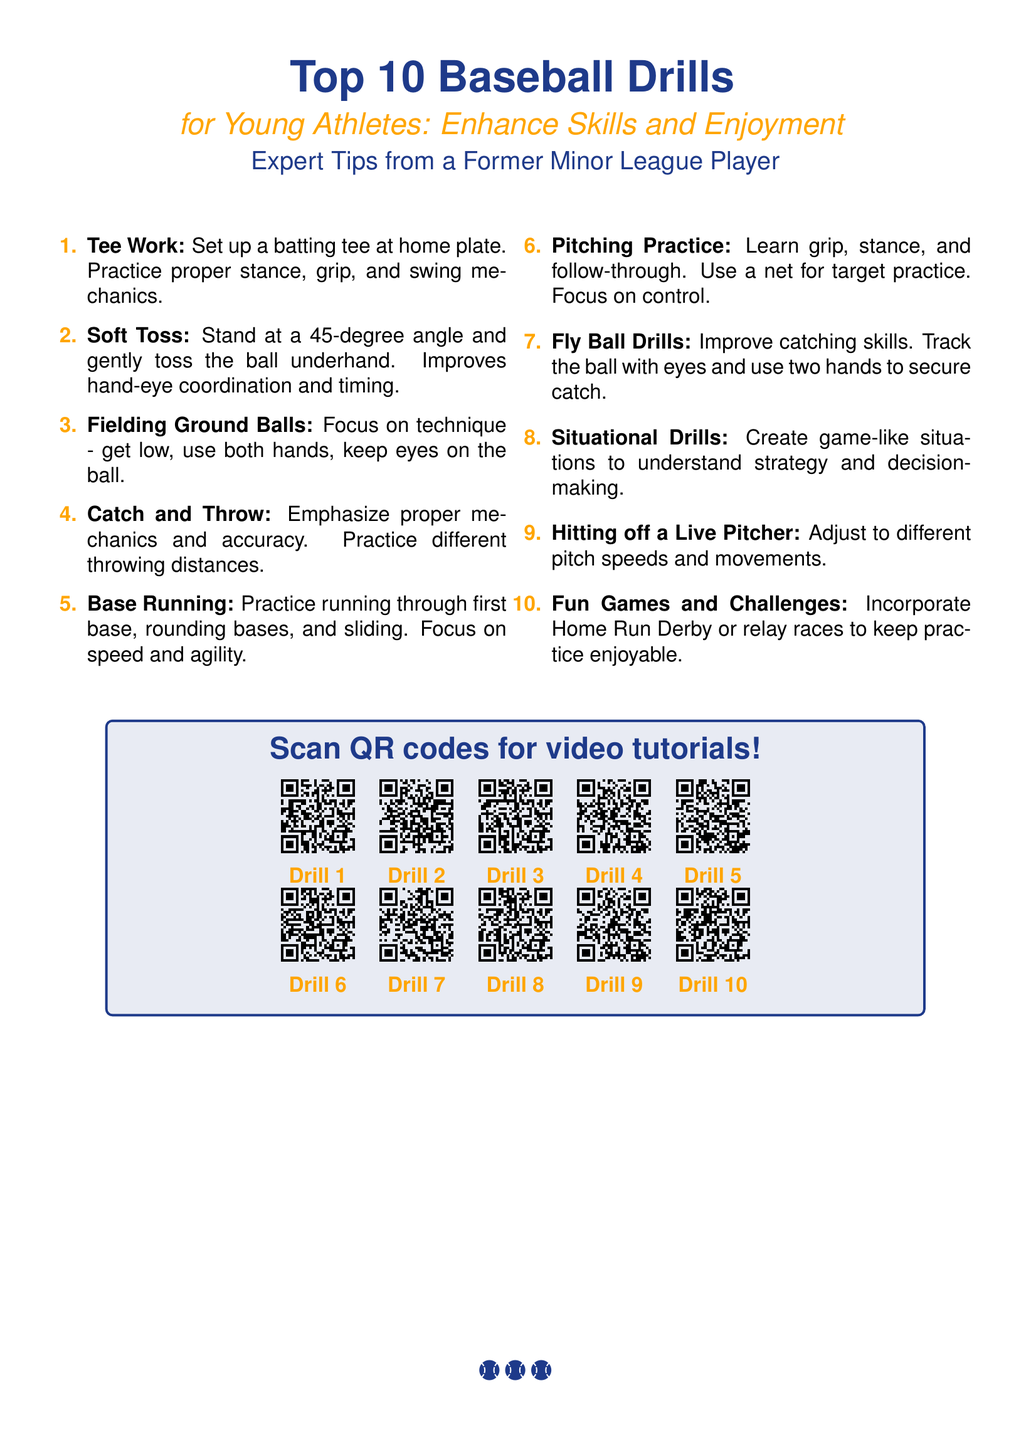What is the title of the flyer? The title of the flyer is prominently displayed at the top and reads "Top 10 Baseball Drills."
Answer: Top 10 Baseball Drills How many drills are listed in the document? The document enumerates each drill, making it clear that there are ten drills in total.
Answer: 10 What is the color used for the accent in the flyer? The accent color is mentioned in the document and is identified by its HTML code.
Answer: #FFA500 Which drill focuses on improving hand-eye coordination and timing? The document describes the purpose of the drills, indicating that Soft Toss is aimed at improving hand-eye coordination and timing.
Answer: Soft Toss What is emphasized during the Pitching Practice drill? The document mentions the focus points for the Pitching Practice, indicating it emphasizes mechanics and control.
Answer: Grip, stance, and follow-through What type of games does the flyer suggest to keep practice enjoyable? The flyer provides examples of fun activities to incorporate, specifically naming games for enjoyment during practice.
Answer: Home Run Derby How can users access video tutorials for the drills? The document includes instructions for accessing the video tutorials, specifically mentioning QR codes for scanning.
Answer: Scan QR codes What is the main objective of the Situational Drills? The description in the document clarifies that these drills are designed to help understand strategy and decision-making.
Answer: Strategy and decision-making What are two examples of drills listed in the flyer? The document lists multiple drills; two examples can be easily derived from the enumeration.
Answer: Tee Work, Fielding Ground Balls 